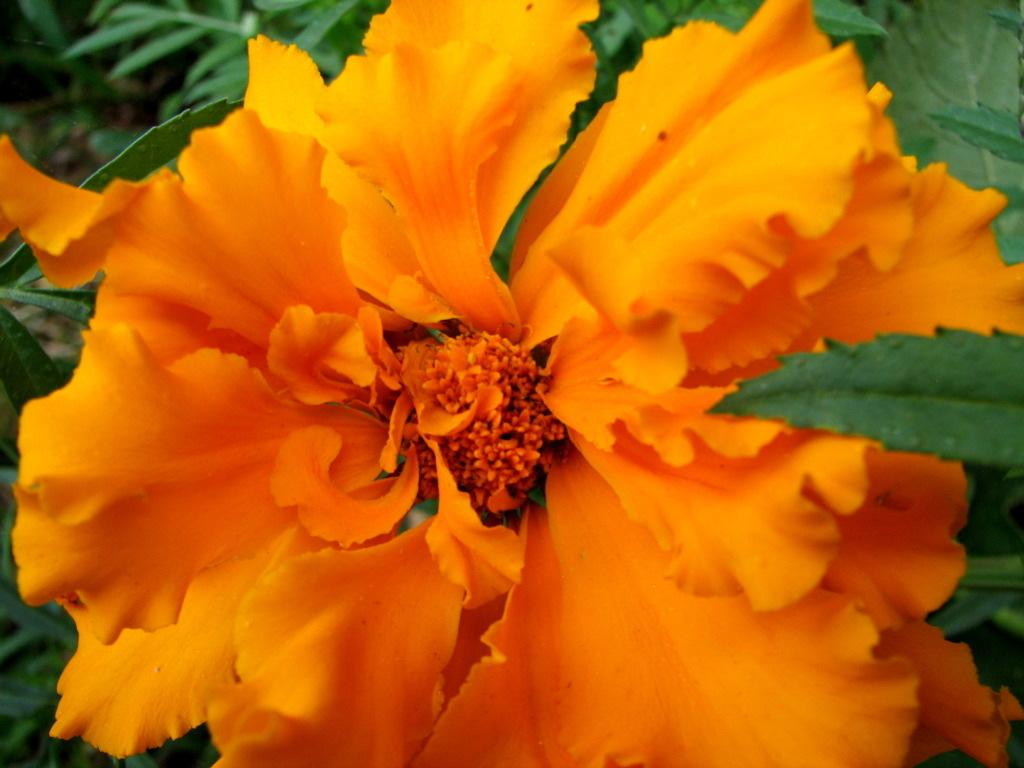What type of plant material is present in the image? There are leaves in the image. What is the main focus of the image? There is a flower in the middle of the image. How many snakes are slithering around the flower in the image? There are no snakes present in the image; it only features leaves and a flower. 